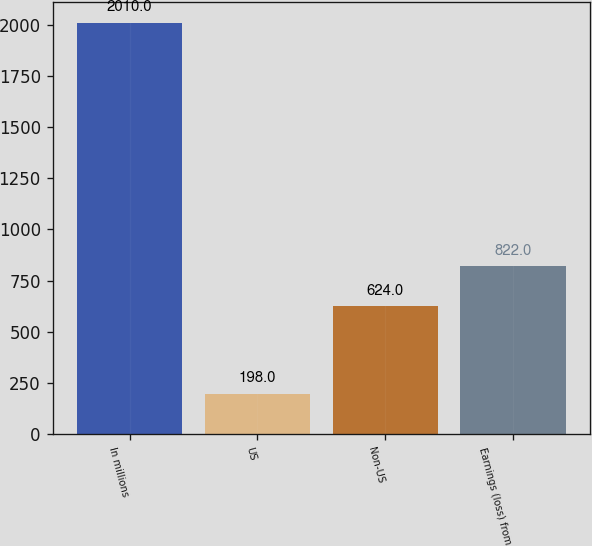<chart> <loc_0><loc_0><loc_500><loc_500><bar_chart><fcel>In millions<fcel>US<fcel>Non-US<fcel>Earnings (loss) from<nl><fcel>2010<fcel>198<fcel>624<fcel>822<nl></chart> 